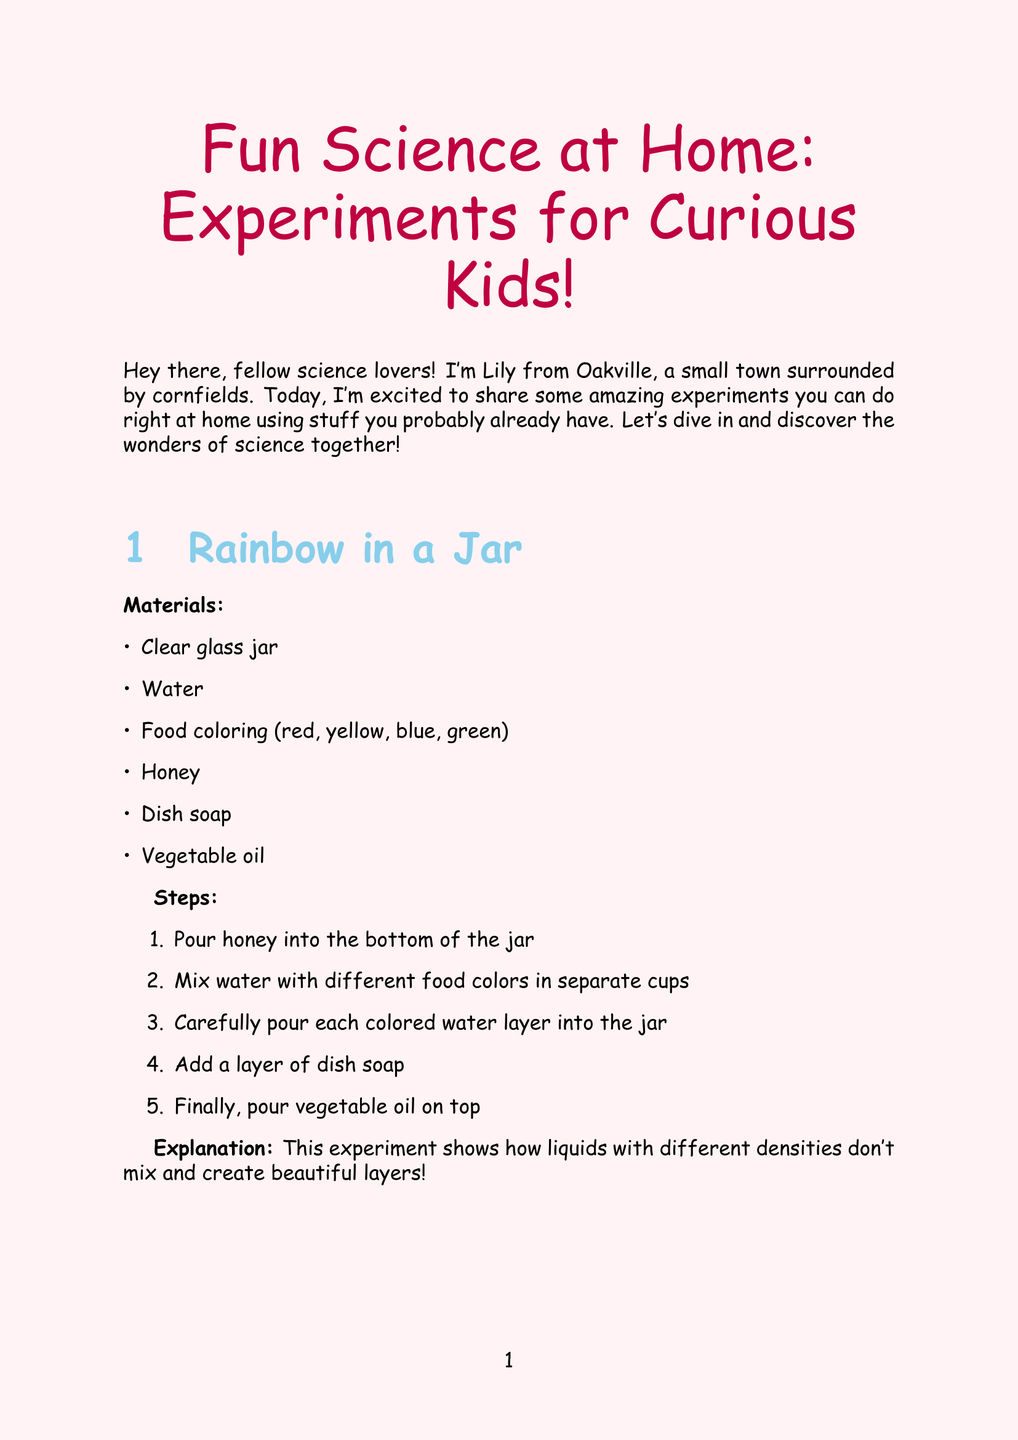What is the title of the newsletter? The title is stated at the beginning of the document.
Answer: Fun Science at Home: Experiments for Curious Kids! Who is the author of the newsletter? The section about the author provides the name.
Answer: Lily How many experiments are included? The number of experiments is mentioned in the list.
Answer: Three What is the first experiment listed? The title of the first experiment is shown in the experiments section.
Answer: Rainbow in a Jar What material is used in the Erupting Volcano experiment? The materials for each experiment are listed explicitly.
Answer: Baking soda What happens to the raisins in the Dancing Raisins experiment? The explanation details the behavior of the raisins during the experiment.
Answer: Dance up and down What should you do before starting an experiment? The safety tips section advises on preparation.
Answer: Ask an adult for help What is the main purpose of the newsletter? The introduction indicates the intent of the newsletter.
Answer: Share amazing experiments How old is the author? The author information gives Lily's age.
Answer: 12 years old 